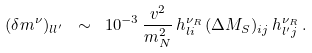Convert formula to latex. <formula><loc_0><loc_0><loc_500><loc_500>( \delta m ^ { \nu } ) _ { l l ^ { \prime } } \ \sim \ 1 0 ^ { - 3 } \, \frac { v ^ { 2 } } { m ^ { 2 } _ { N } } \, h ^ { \nu _ { R } } _ { l i } \, ( \Delta M _ { S } ) _ { i j } \, h ^ { \nu _ { R } } _ { l ^ { \prime } j } \, .</formula> 